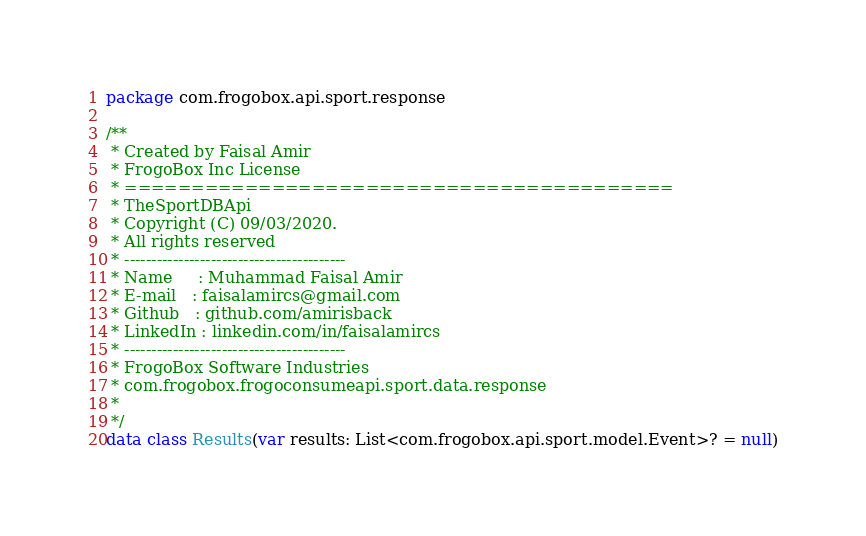<code> <loc_0><loc_0><loc_500><loc_500><_Kotlin_>package com.frogobox.api.sport.response

/**
 * Created by Faisal Amir
 * FrogoBox Inc License
 * =========================================
 * TheSportDBApi
 * Copyright (C) 09/03/2020.
 * All rights reserved
 * -----------------------------------------
 * Name     : Muhammad Faisal Amir
 * E-mail   : faisalamircs@gmail.com
 * Github   : github.com/amirisback
 * LinkedIn : linkedin.com/in/faisalamircs
 * -----------------------------------------
 * FrogoBox Software Industries
 * com.frogobox.frogoconsumeapi.sport.data.response
 *
 */
data class Results(var results: List<com.frogobox.api.sport.model.Event>? = null)</code> 